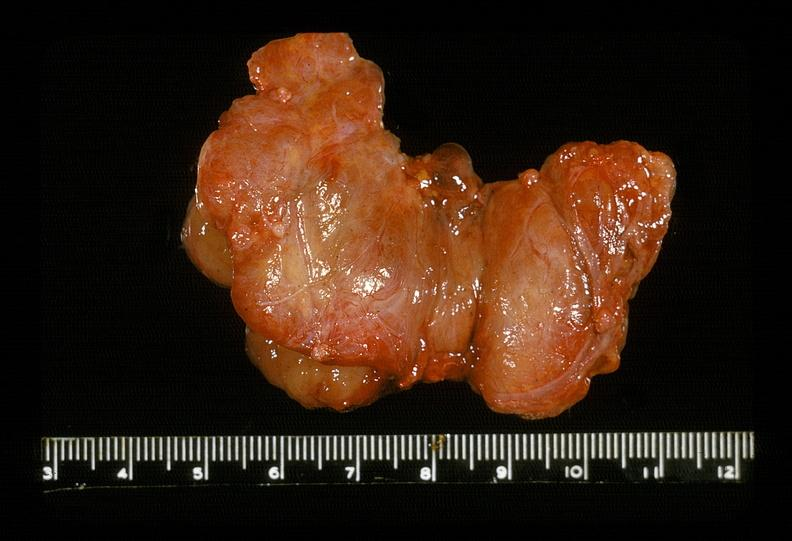does coronary artery show thyroid, hashimotos?
Answer the question using a single word or phrase. No 